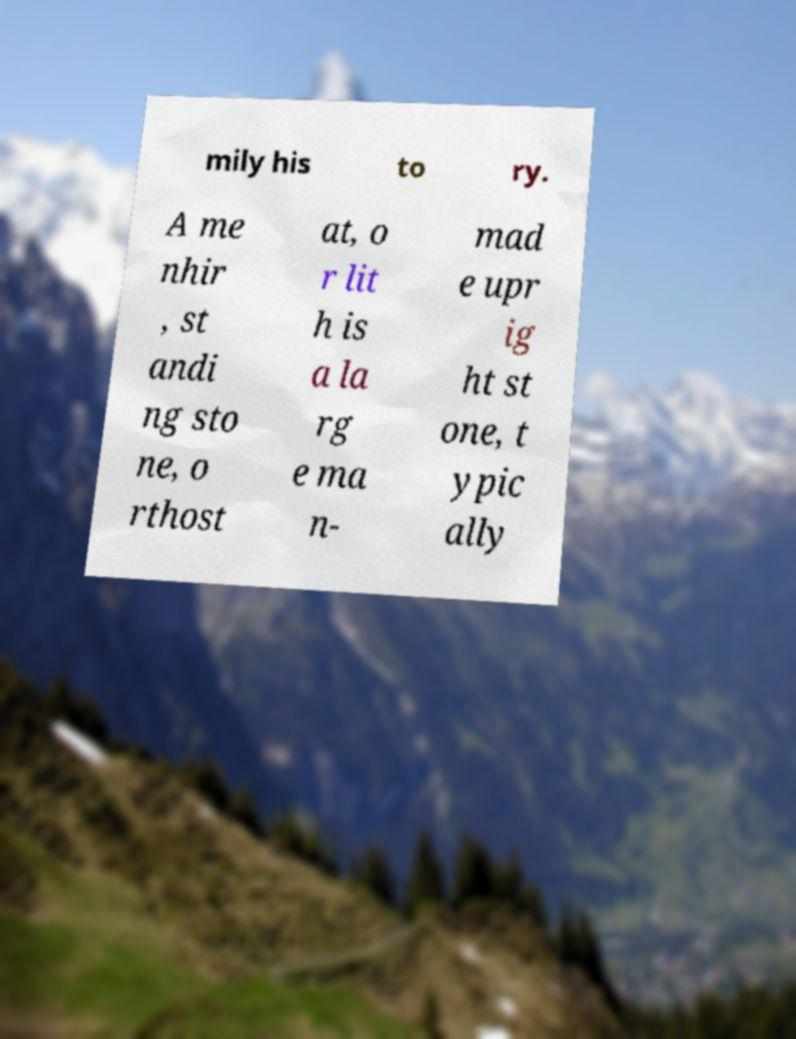What messages or text are displayed in this image? I need them in a readable, typed format. mily his to ry. A me nhir , st andi ng sto ne, o rthost at, o r lit h is a la rg e ma n- mad e upr ig ht st one, t ypic ally 